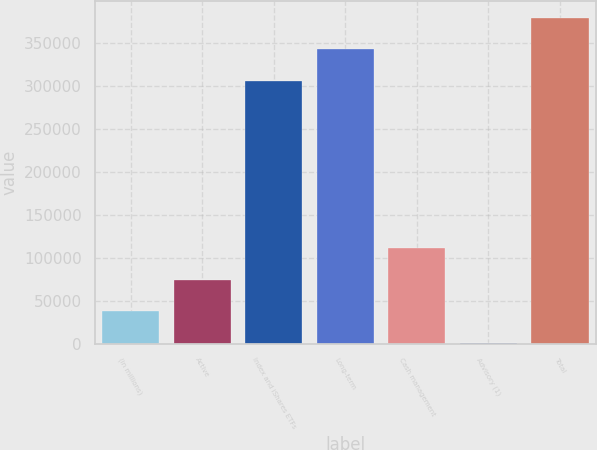<chart> <loc_0><loc_0><loc_500><loc_500><bar_chart><fcel>(in millions)<fcel>Active<fcel>Index and iShares ETFs<fcel>Long-term<fcel>Cash management<fcel>Advisory (1)<fcel>Total<nl><fcel>37845.9<fcel>74446.8<fcel>305791<fcel>342392<fcel>111048<fcel>1245<fcel>378993<nl></chart> 